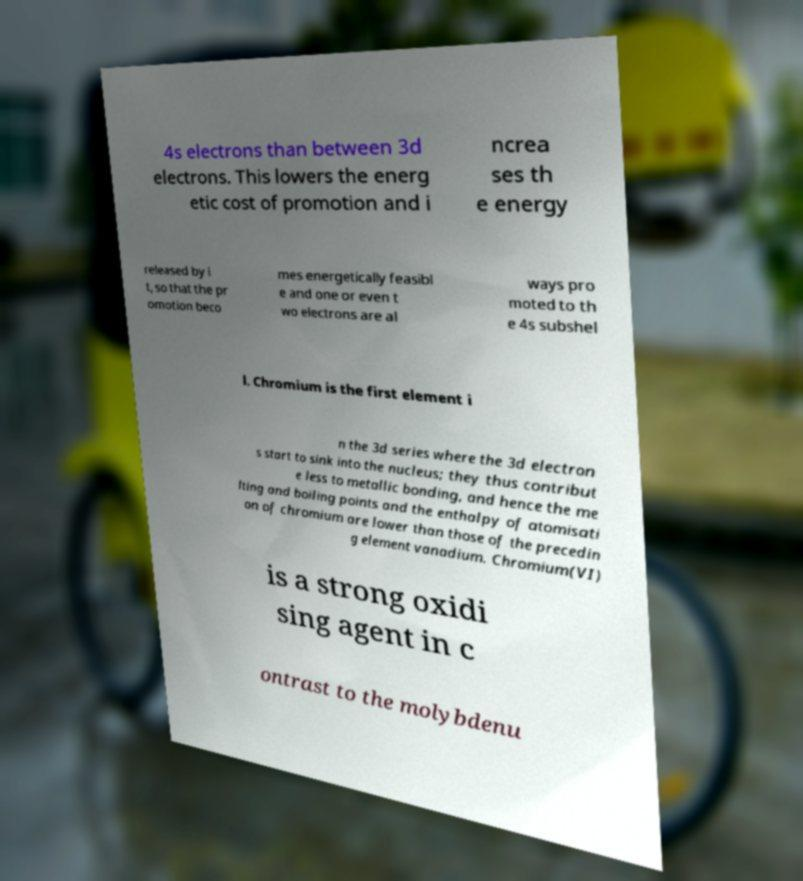I need the written content from this picture converted into text. Can you do that? 4s electrons than between 3d electrons. This lowers the energ etic cost of promotion and i ncrea ses th e energy released by i t, so that the pr omotion beco mes energetically feasibl e and one or even t wo electrons are al ways pro moted to th e 4s subshel l. Chromium is the first element i n the 3d series where the 3d electron s start to sink into the nucleus; they thus contribut e less to metallic bonding, and hence the me lting and boiling points and the enthalpy of atomisati on of chromium are lower than those of the precedin g element vanadium. Chromium(VI) is a strong oxidi sing agent in c ontrast to the molybdenu 